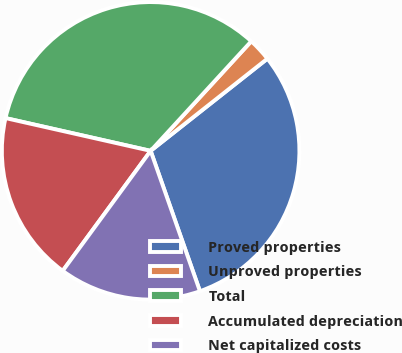Convert chart. <chart><loc_0><loc_0><loc_500><loc_500><pie_chart><fcel>Proved properties<fcel>Unproved properties<fcel>Total<fcel>Accumulated depreciation<fcel>Net capitalized costs<nl><fcel>30.26%<fcel>2.54%<fcel>33.29%<fcel>18.47%<fcel>15.44%<nl></chart> 